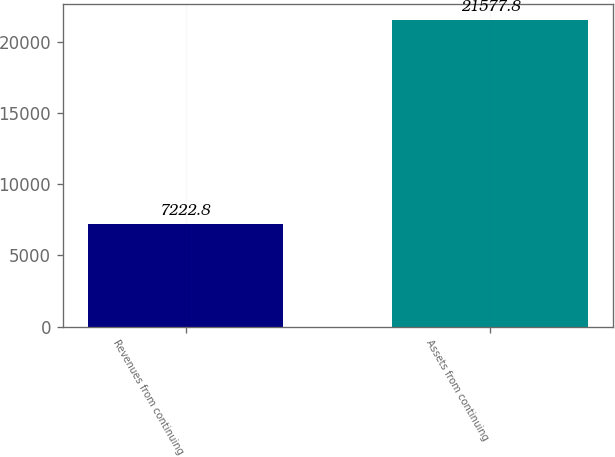<chart> <loc_0><loc_0><loc_500><loc_500><bar_chart><fcel>Revenues from continuing<fcel>Assets from continuing<nl><fcel>7222.8<fcel>21577.8<nl></chart> 